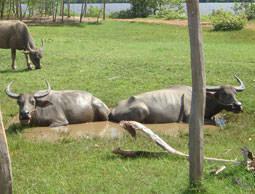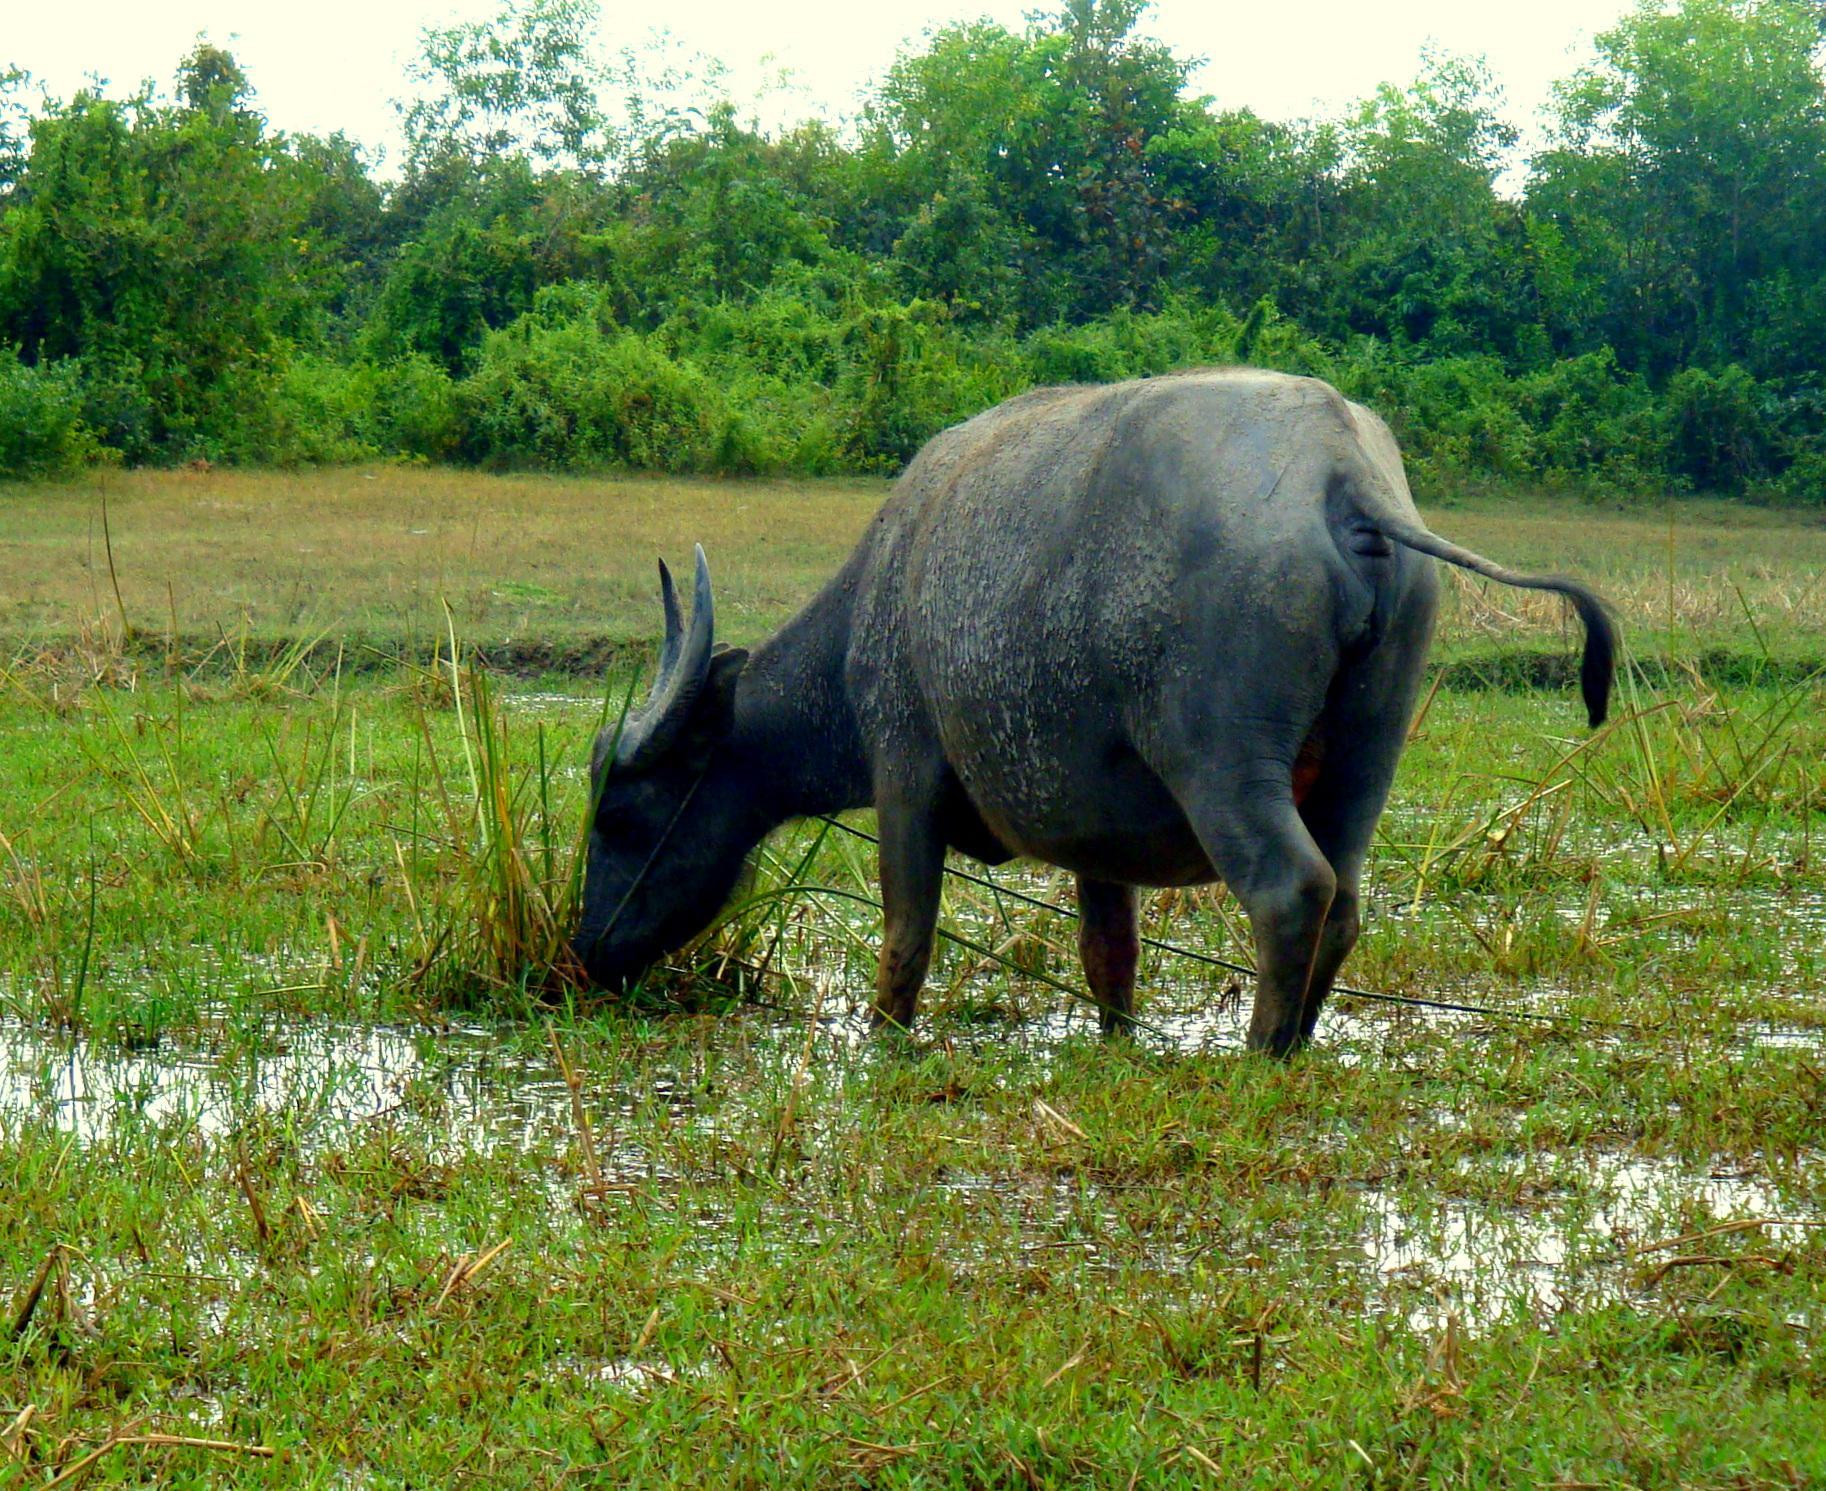The first image is the image on the left, the second image is the image on the right. Assess this claim about the two images: "A young person wearing head covering is sitting astride a horned animal.". Correct or not? Answer yes or no. No. The first image is the image on the left, the second image is the image on the right. Given the left and right images, does the statement "One of the pictures shows a boy riding a water buffalo, and the other shows two water buffalo together." hold true? Answer yes or no. No. 